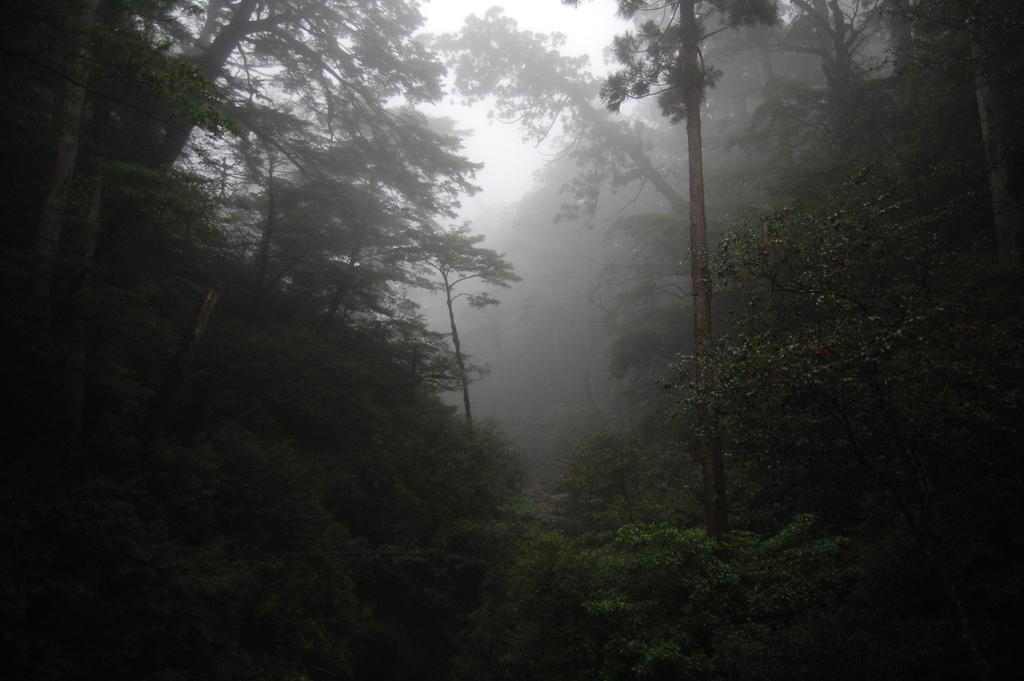What type of vegetation can be seen in the image? There are trees in the image. What else is visible in the image besides the trees? There is smoke visible in the image, and the sky is also visible. Can you describe the setting of the image? The image may have been taken in a forest, given the presence of trees. What items are on the list in the image? There is no list present in the image. What type of insect can be seen in the image? There are no insects visible in the image. 